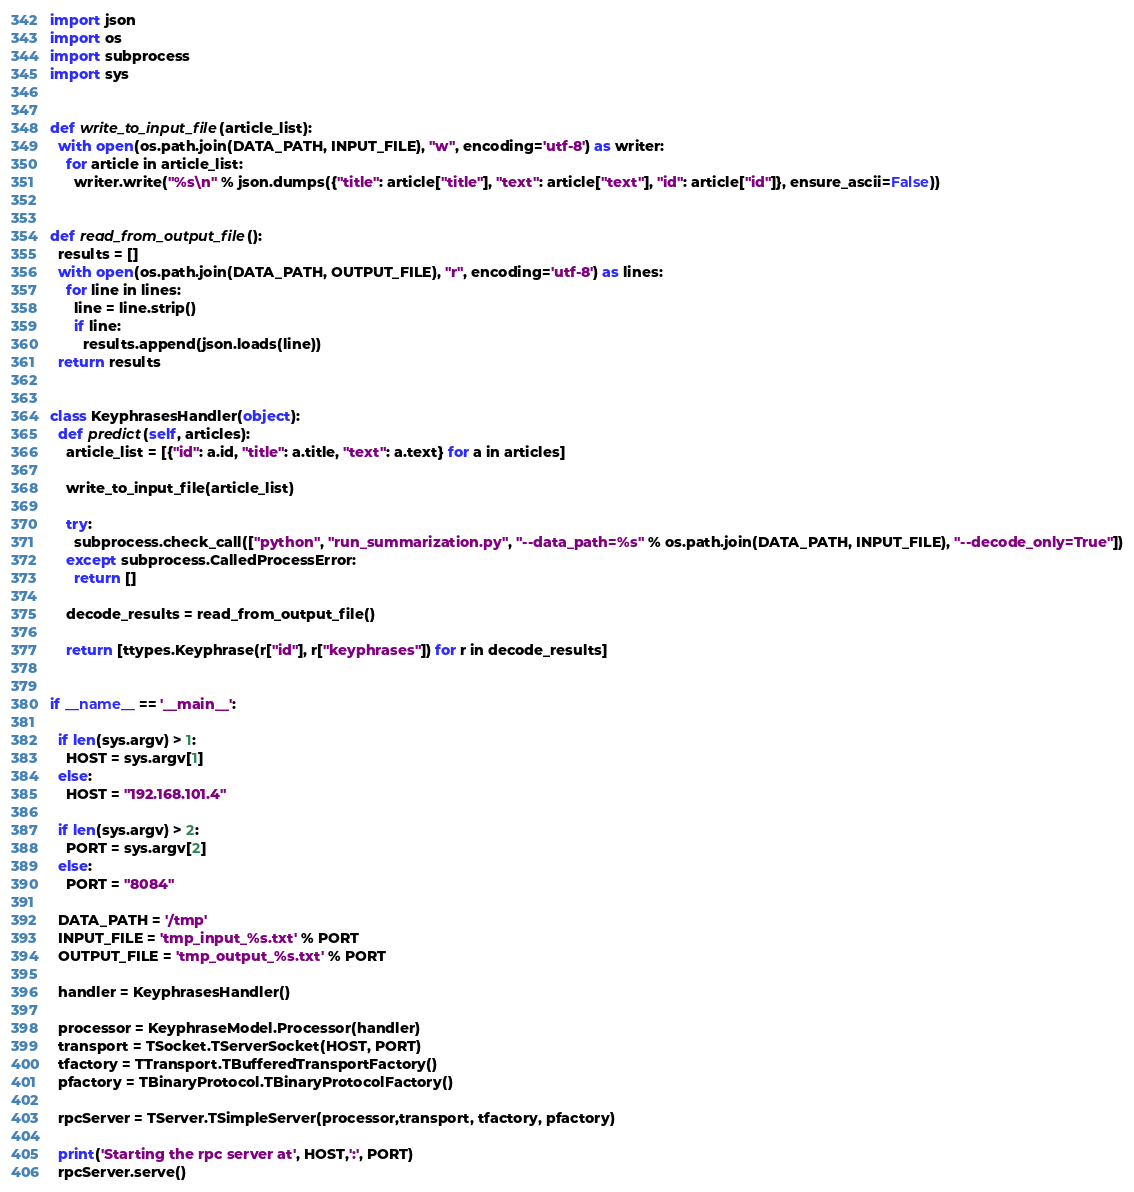Convert code to text. <code><loc_0><loc_0><loc_500><loc_500><_Python_>import json
import os
import subprocess
import sys


def write_to_input_file(article_list):
  with open(os.path.join(DATA_PATH, INPUT_FILE), "w", encoding='utf-8') as writer:
    for article in article_list:
      writer.write("%s\n" % json.dumps({"title": article["title"], "text": article["text"], "id": article["id"]}, ensure_ascii=False))


def read_from_output_file():
  results = []
  with open(os.path.join(DATA_PATH, OUTPUT_FILE), "r", encoding='utf-8') as lines:
    for line in lines:
      line = line.strip()
      if line:
        results.append(json.loads(line))
  return results


class KeyphrasesHandler(object):
  def predict(self, articles):
    article_list = [{"id": a.id, "title": a.title, "text": a.text} for a in articles]

    write_to_input_file(article_list)

    try:
      subprocess.check_call(["python", "run_summarization.py", "--data_path=%s" % os.path.join(DATA_PATH, INPUT_FILE), "--decode_only=True"])
    except subprocess.CalledProcessError:
      return []

    decode_results = read_from_output_file()

    return [ttypes.Keyphrase(r["id"], r["keyphrases"]) for r in decode_results]


if __name__ == '__main__':

  if len(sys.argv) > 1:
    HOST = sys.argv[1]
  else:
    HOST = "192.168.101.4"

  if len(sys.argv) > 2:
    PORT = sys.argv[2]
  else:
    PORT = "8084"

  DATA_PATH = '/tmp'
  INPUT_FILE = 'tmp_input_%s.txt' % PORT
  OUTPUT_FILE = 'tmp_output_%s.txt' % PORT

  handler = KeyphrasesHandler()

  processor = KeyphraseModel.Processor(handler)
  transport = TSocket.TServerSocket(HOST, PORT)
  tfactory = TTransport.TBufferedTransportFactory()
  pfactory = TBinaryProtocol.TBinaryProtocolFactory()

  rpcServer = TServer.TSimpleServer(processor,transport, tfactory, pfactory)

  print('Starting the rpc server at', HOST,':', PORT)
  rpcServer.serve()
</code> 